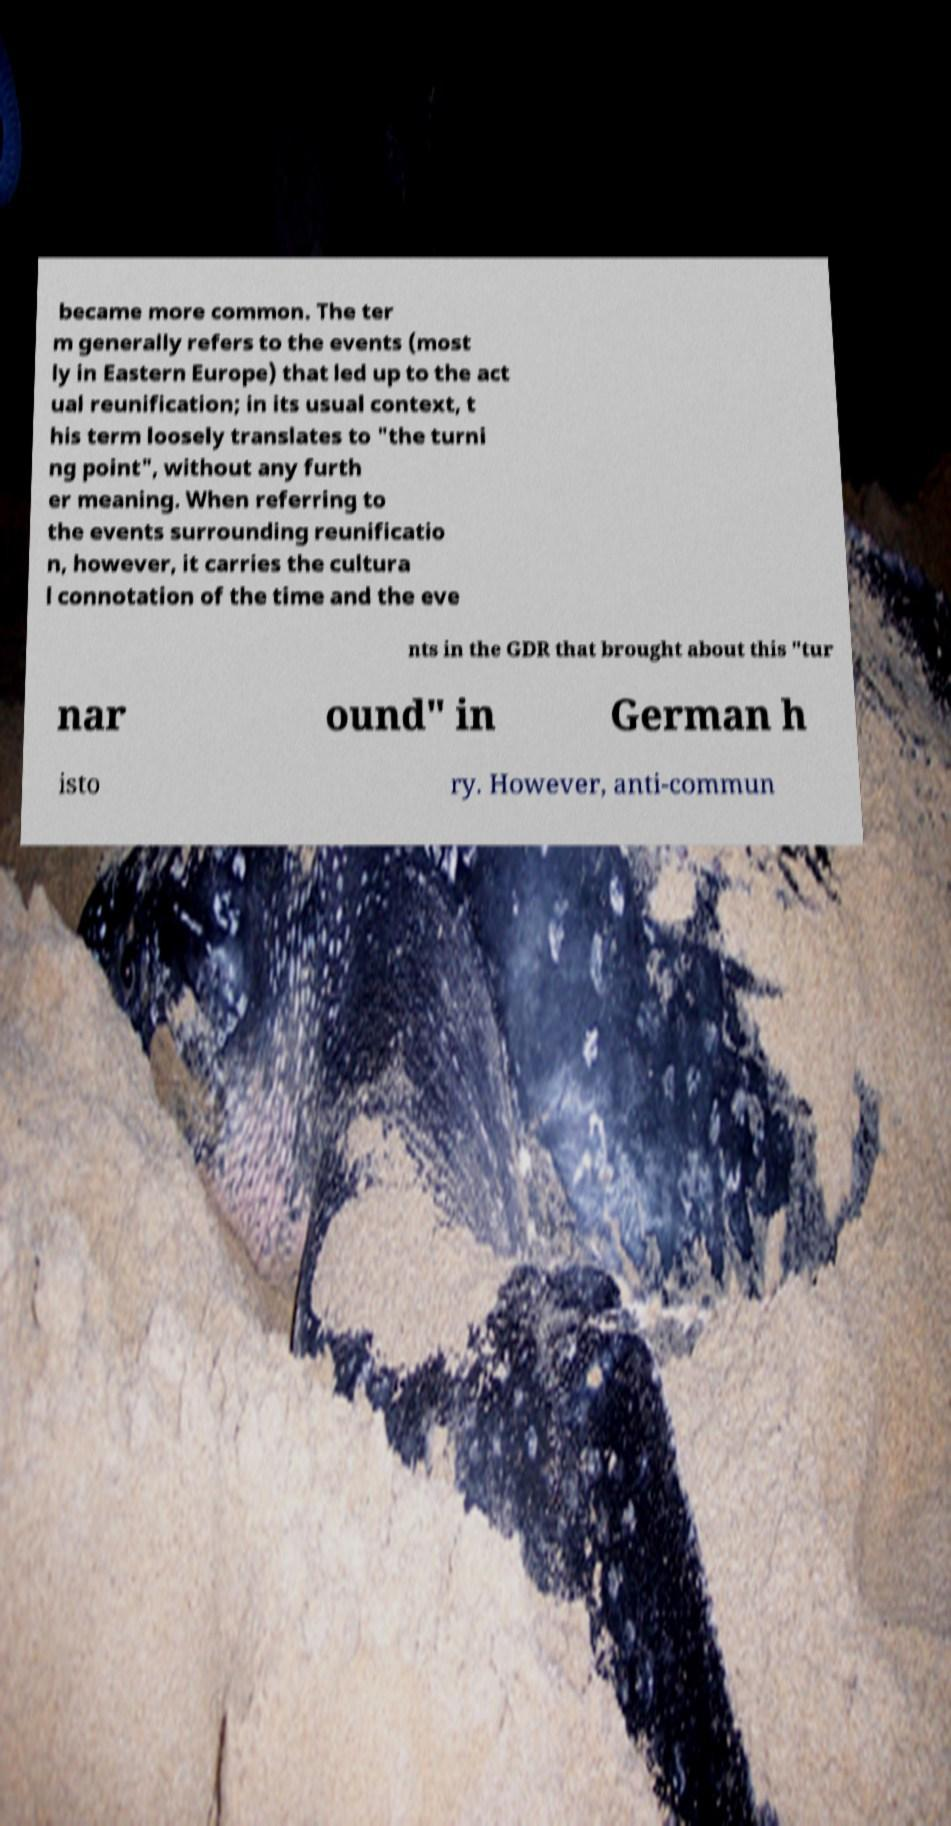Can you accurately transcribe the text from the provided image for me? became more common. The ter m generally refers to the events (most ly in Eastern Europe) that led up to the act ual reunification; in its usual context, t his term loosely translates to "the turni ng point", without any furth er meaning. When referring to the events surrounding reunificatio n, however, it carries the cultura l connotation of the time and the eve nts in the GDR that brought about this "tur nar ound" in German h isto ry. However, anti-commun 